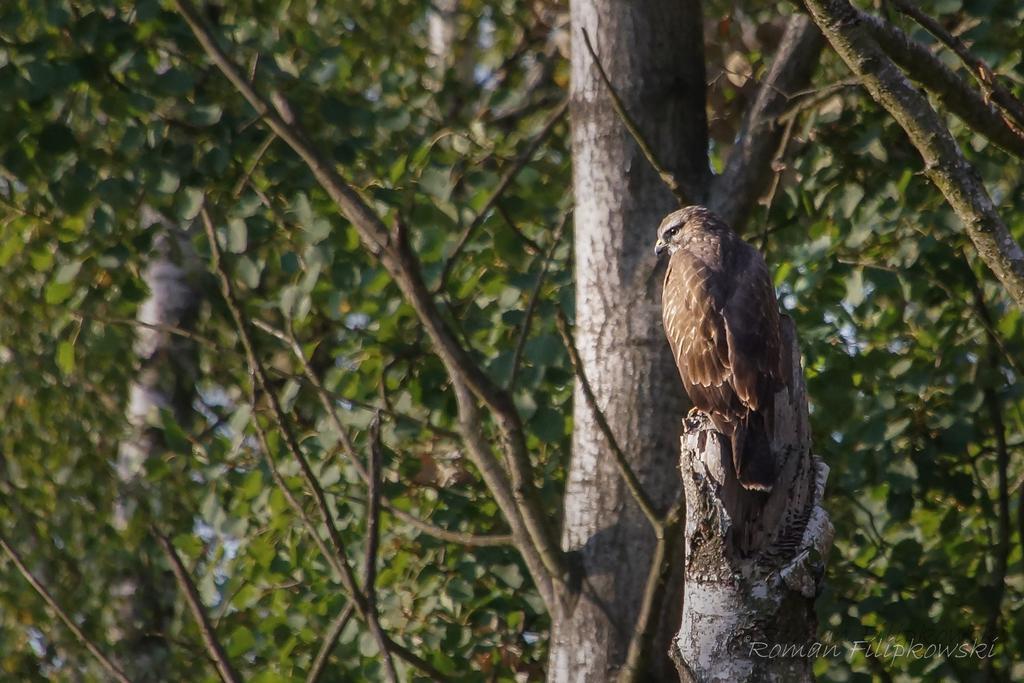In one or two sentences, can you explain what this image depicts? It is a zoom in picture of a bird present on the bark of a tree. At the bottom there is logo. 